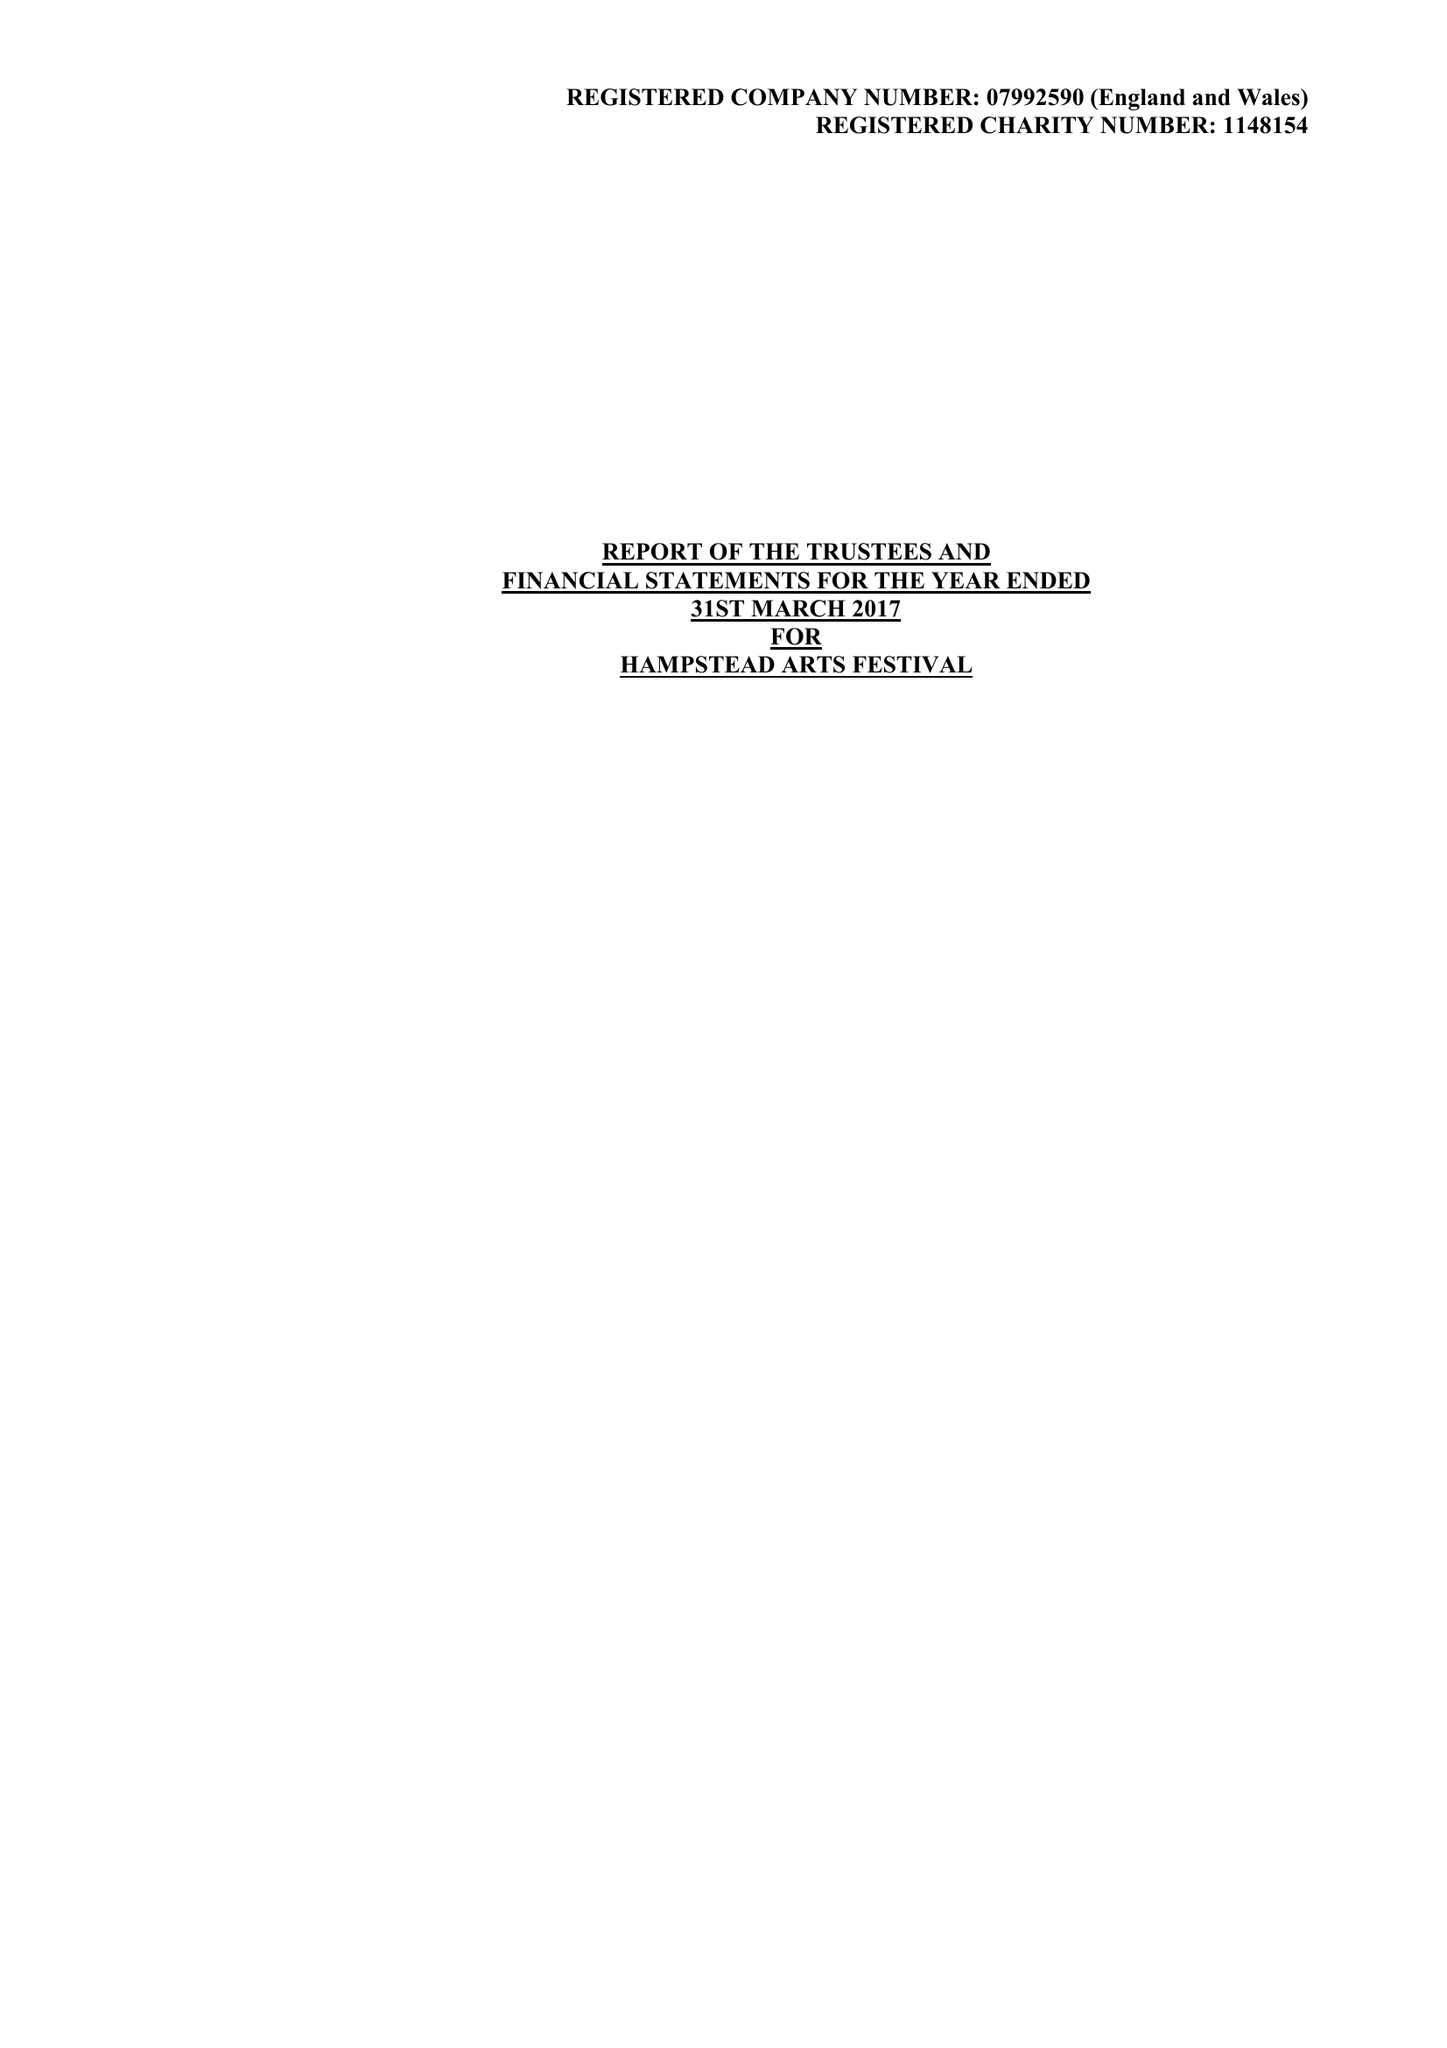What is the value for the income_annually_in_british_pounds?
Answer the question using a single word or phrase. 41951.00 